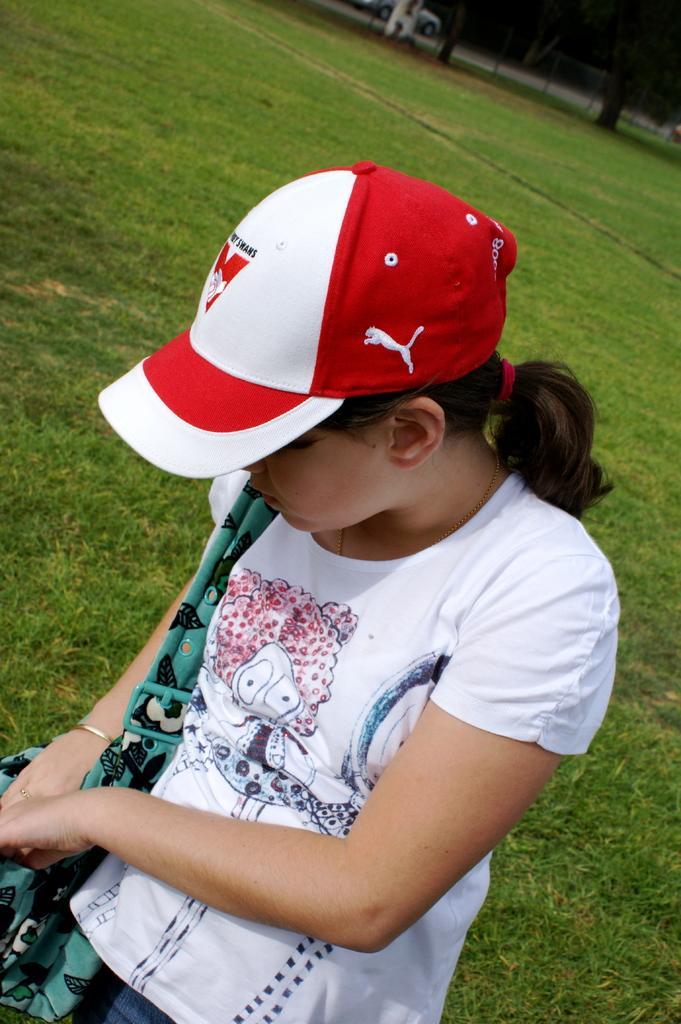Could you give a brief overview of what you see in this image? In this image we can see a person wearing a cap and a handbag on the ground. 